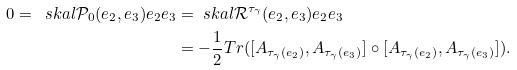<formula> <loc_0><loc_0><loc_500><loc_500>0 = \ s k a l { \mathcal { P } _ { 0 } ( e _ { 2 } , e _ { 3 } ) e _ { 2 } } { e _ { 3 } } & = \ s k a l { \mathcal { R } ^ { \tau _ { \gamma } } ( e _ { 2 } , e _ { 3 } ) e _ { 2 } } { e _ { 3 } } \\ & = - \frac { 1 } { 2 } T r ( [ A _ { \tau _ { \gamma } ( e _ { 2 } ) } , A _ { \tau _ { \gamma } ( e _ { 3 } ) } ] \circ [ A _ { \tau _ { \gamma } ( e _ { 2 } ) } , A _ { \tau _ { \gamma } ( e _ { 3 } ) } ] ) .</formula> 